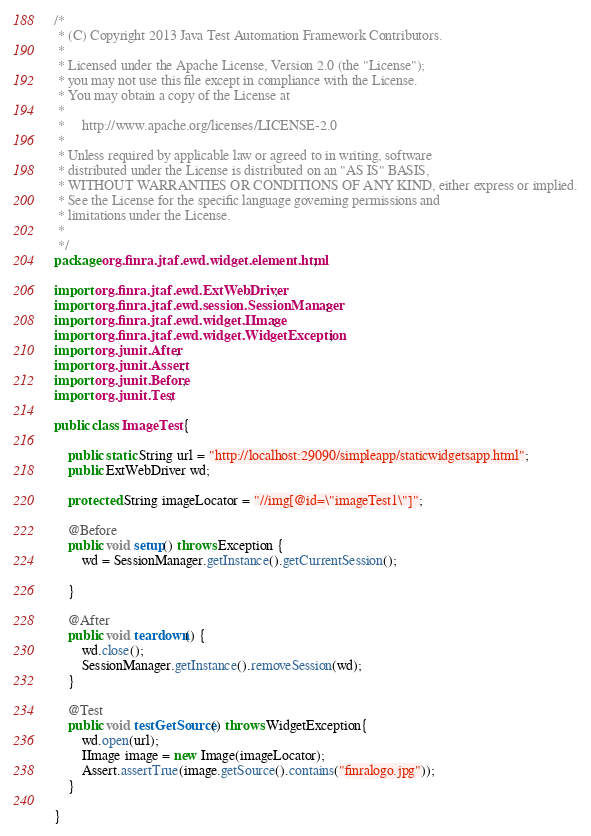Convert code to text. <code><loc_0><loc_0><loc_500><loc_500><_Java_>/*
 * (C) Copyright 2013 Java Test Automation Framework Contributors.
 *
 * Licensed under the Apache License, Version 2.0 (the "License");
 * you may not use this file except in compliance with the License.
 * You may obtain a copy of the License at
 *
 *     http://www.apache.org/licenses/LICENSE-2.0
 *
 * Unless required by applicable law or agreed to in writing, software
 * distributed under the License is distributed on an "AS IS" BASIS,
 * WITHOUT WARRANTIES OR CONDITIONS OF ANY KIND, either express or implied.
 * See the License for the specific language governing permissions and
 * limitations under the License.
 *
 */
package org.finra.jtaf.ewd.widget.element.html;

import org.finra.jtaf.ewd.ExtWebDriver;
import org.finra.jtaf.ewd.session.SessionManager;
import org.finra.jtaf.ewd.widget.IImage;
import org.finra.jtaf.ewd.widget.WidgetException;
import org.junit.After;
import org.junit.Assert;
import org.junit.Before;
import org.junit.Test;

public class ImageTest {

    public static String url = "http://localhost:29090/simpleapp/staticwidgetsapp.html";
    public ExtWebDriver wd;
	
	protected String imageLocator = "//img[@id=\"imageTest1\"]";
    
	@Before
    public void setup() throws Exception {
        wd = SessionManager.getInstance().getCurrentSession();
        
    }

    @After
    public void teardown() {
        wd.close();
        SessionManager.getInstance().removeSession(wd);
    }
    
    @Test
    public void testGetSource() throws WidgetException{
    	wd.open(url);
    	IImage image = new Image(imageLocator);
    	Assert.assertTrue(image.getSource().contains("finralogo.jpg"));
    }
    
}
</code> 